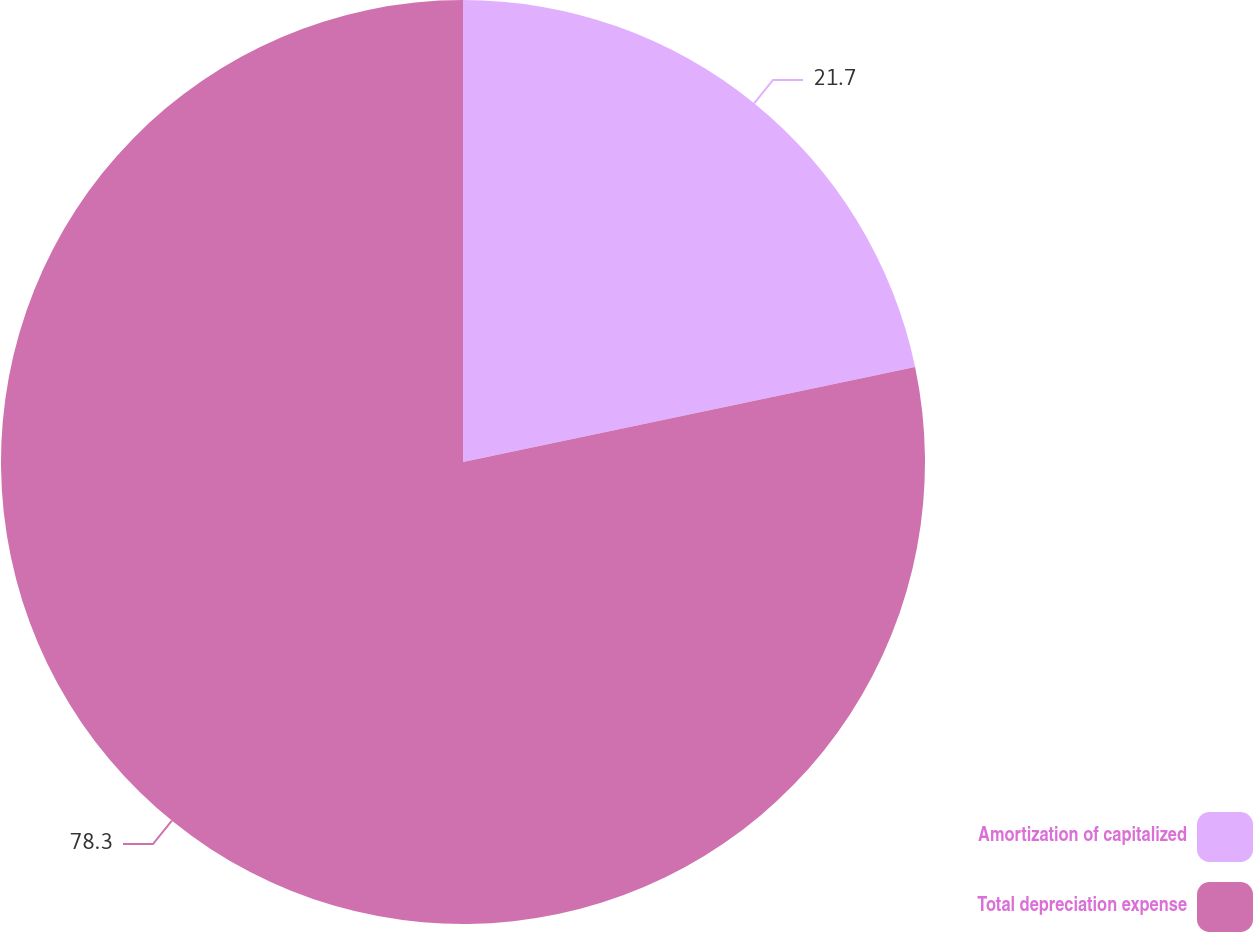Convert chart. <chart><loc_0><loc_0><loc_500><loc_500><pie_chart><fcel>Amortization of capitalized<fcel>Total depreciation expense<nl><fcel>21.7%<fcel>78.3%<nl></chart> 